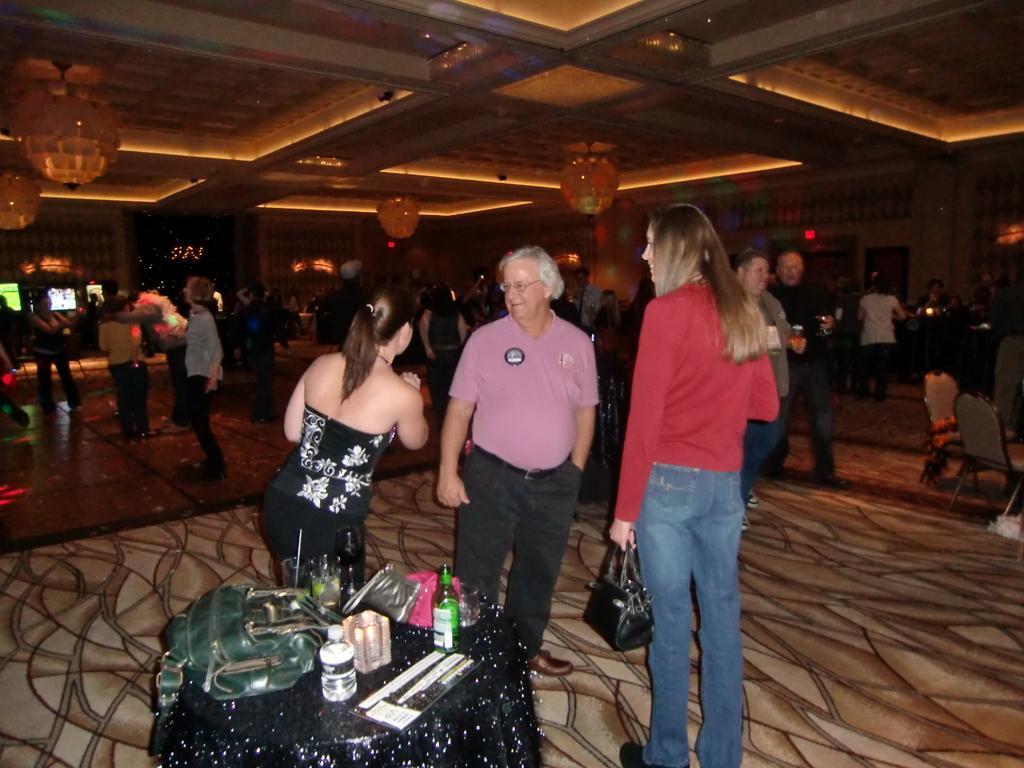In one or two sentences, can you explain what this image depicts? there are group of people standing. This is a table covered with black cloth. I can see a bottle,pouch,handbag and some other objects placed on the table. These are the ceiling lights hanging through the roof top. 